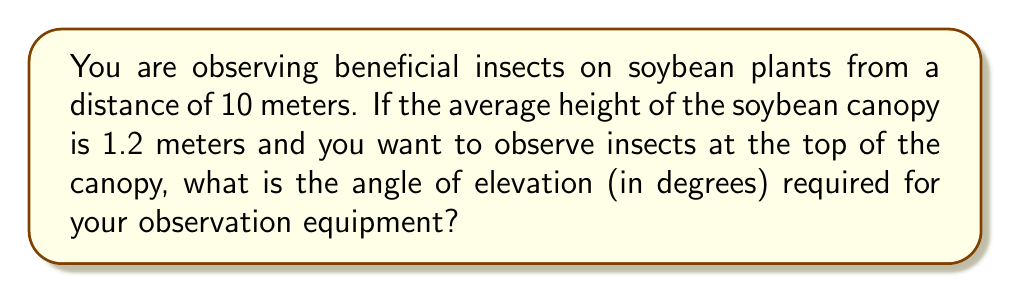Teach me how to tackle this problem. To solve this problem, we need to use trigonometry. Let's break it down step-by-step:

1. Visualize the scenario:
   [asy]
   import geometry;
   
   size(200);
   
   pair A = (0,0);
   pair B = (10,0);
   pair C = (10,1.2);
   
   draw(A--B--C--A);
   
   label("Observer", A, SW);
   label("10 m", (5,0), S);
   label("1.2 m", (10,0.6), E);
   label("θ", (0.5,0), NW);
   
   draw(arc(A,0.5,0,degrees(atan(1.2/10))),Arrow);
   [/asy]

2. Identify the trigonometric function to use:
   We have the opposite side (height of canopy) and the adjacent side (distance to the plant).
   This forms a right triangle where we need to find the angle.
   The tangent function relates the opposite and adjacent sides: $\tan(\theta) = \frac{\text{opposite}}{\text{adjacent}}$

3. Set up the equation:
   $\tan(\theta) = \frac{1.2 \text{ m}}{10 \text{ m}}$

4. Solve for θ using the inverse tangent (arctangent) function:
   $\theta = \tan^{-1}\left(\frac{1.2}{10}\right)$

5. Calculate the result:
   $\theta = \tan^{-1}(0.12)$
   $\theta \approx 6.84^\circ$

6. Round to two decimal places:
   $\theta \approx 6.84^\circ$
Answer: $6.84^\circ$ 